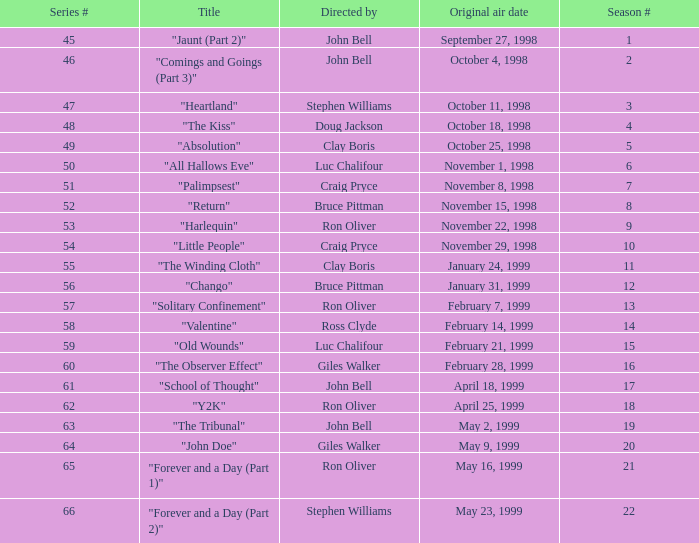Which Season # has a Title of "jaunt (part 2)", and a Series # larger than 45? None. 